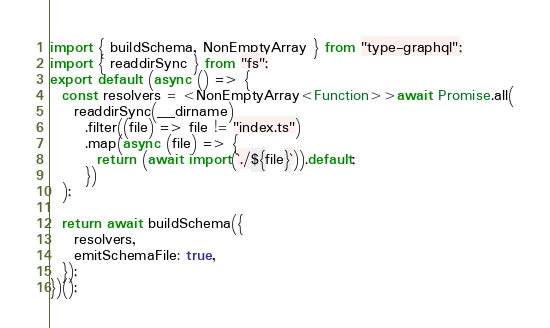<code> <loc_0><loc_0><loc_500><loc_500><_TypeScript_>import { buildSchema, NonEmptyArray } from "type-graphql";
import { readdirSync } from "fs";
export default (async () => {
  const resolvers = <NonEmptyArray<Function>>await Promise.all(
    readdirSync(__dirname)
      .filter((file) => file != "index.ts")
      .map(async (file) => {
        return (await import(`./${file}`)).default;
      })
  );
  
  return await buildSchema({
    resolvers,
    emitSchemaFile: true,
  });
})();
</code> 